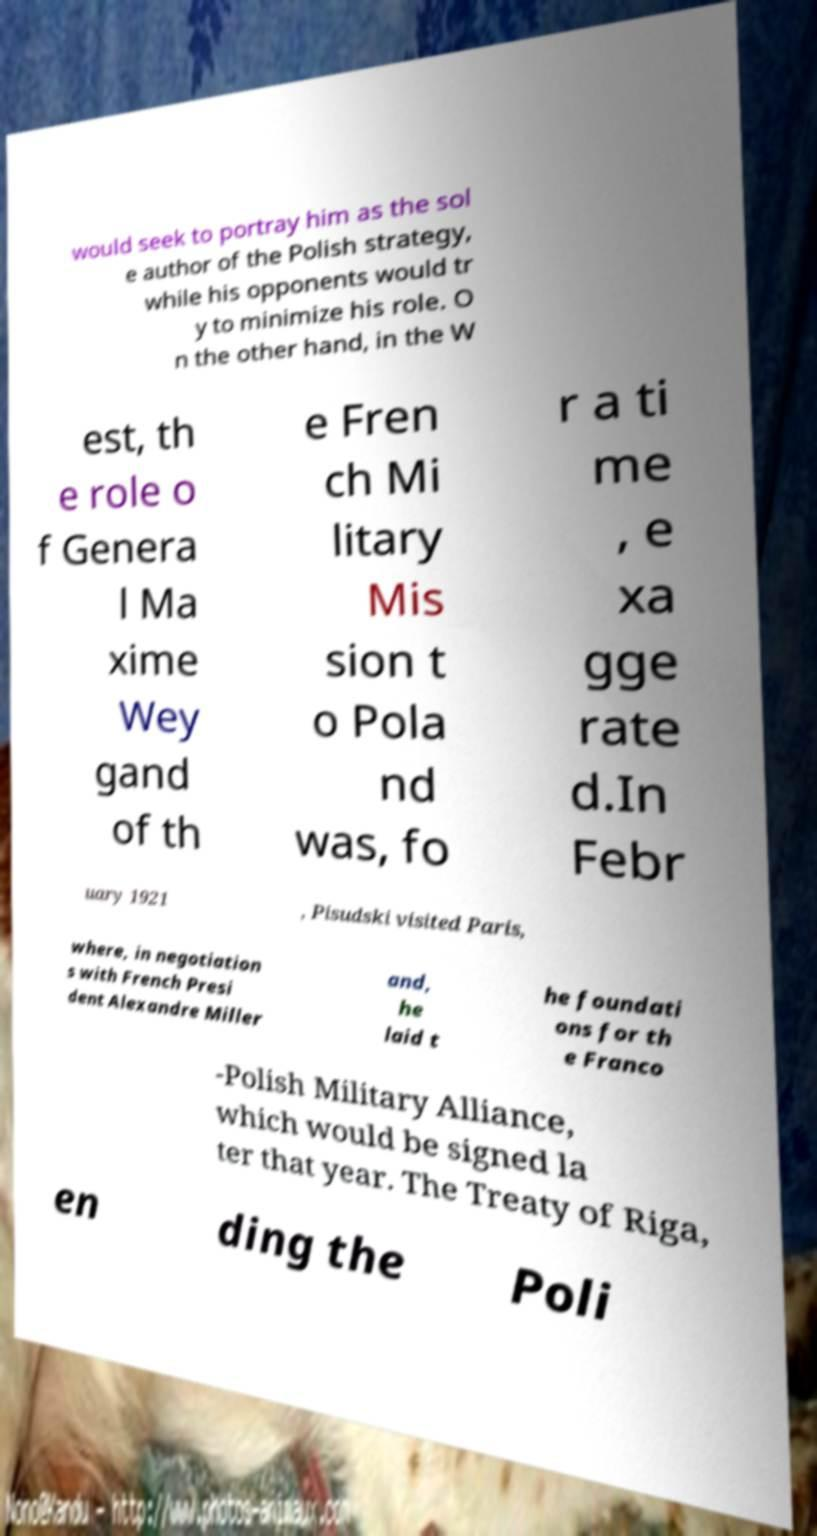Could you extract and type out the text from this image? would seek to portray him as the sol e author of the Polish strategy, while his opponents would tr y to minimize his role. O n the other hand, in the W est, th e role o f Genera l Ma xime Wey gand of th e Fren ch Mi litary Mis sion t o Pola nd was, fo r a ti me , e xa gge rate d.In Febr uary 1921 , Pisudski visited Paris, where, in negotiation s with French Presi dent Alexandre Miller and, he laid t he foundati ons for th e Franco -Polish Military Alliance, which would be signed la ter that year. The Treaty of Riga, en ding the Poli 